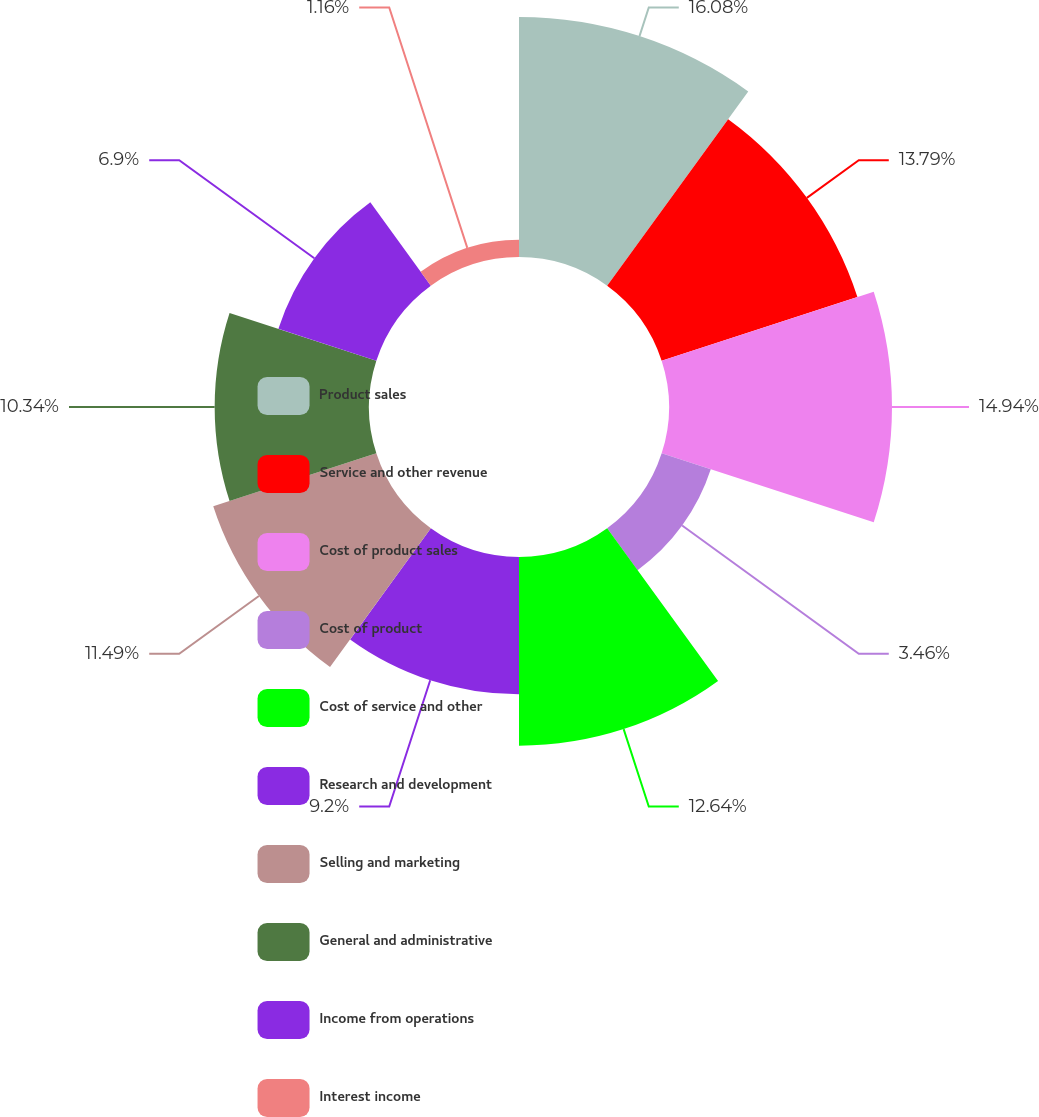Convert chart to OTSL. <chart><loc_0><loc_0><loc_500><loc_500><pie_chart><fcel>Product sales<fcel>Service and other revenue<fcel>Cost of product sales<fcel>Cost of product<fcel>Cost of service and other<fcel>Research and development<fcel>Selling and marketing<fcel>General and administrative<fcel>Income from operations<fcel>Interest income<nl><fcel>16.08%<fcel>13.79%<fcel>14.94%<fcel>3.46%<fcel>12.64%<fcel>9.2%<fcel>11.49%<fcel>10.34%<fcel>6.9%<fcel>1.16%<nl></chart> 